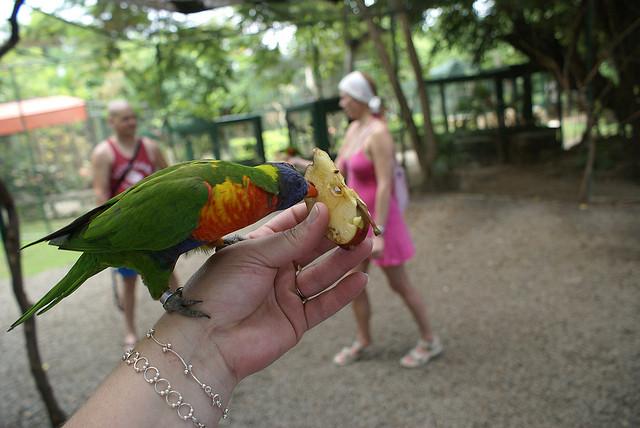What kind of bird is this?
Quick response, please. Parrot. What is the bird eating?
Write a very short answer. Apple. What color is the watchband?
Concise answer only. Silver. Is this photo outdoors?
Write a very short answer. Yes. The person feeding the bird, are they wearing jewelry?
Be succinct. Yes. 